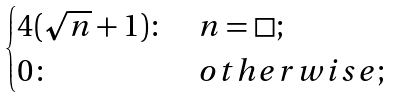<formula> <loc_0><loc_0><loc_500><loc_500>\begin{cases} 4 ( \sqrt { n } + 1 ) \colon & n = \square ; \\ 0 \colon & o t h e r w i s e ; \end{cases}</formula> 